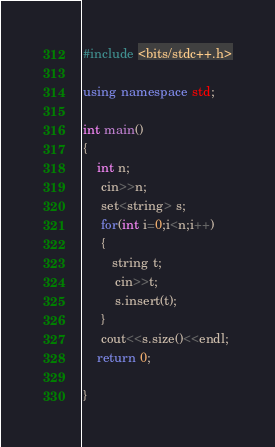Convert code to text. <code><loc_0><loc_0><loc_500><loc_500><_C++_>#include <bits/stdc++.h>

using namespace std;

int main()
{
    int n;
     cin>>n;
     set<string> s;
     for(int i=0;i<n;i++)
     {
     	string t;
     	 cin>>t;
     	 s.insert(t);
	 }
	 cout<<s.size()<<endl;
	return 0;
	
}
</code> 